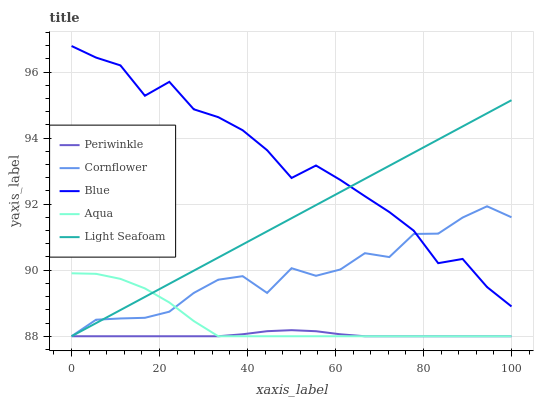Does Periwinkle have the minimum area under the curve?
Answer yes or no. Yes. Does Blue have the maximum area under the curve?
Answer yes or no. Yes. Does Cornflower have the minimum area under the curve?
Answer yes or no. No. Does Cornflower have the maximum area under the curve?
Answer yes or no. No. Is Light Seafoam the smoothest?
Answer yes or no. Yes. Is Blue the roughest?
Answer yes or no. Yes. Is Cornflower the smoothest?
Answer yes or no. No. Is Cornflower the roughest?
Answer yes or no. No. Does Cornflower have the lowest value?
Answer yes or no. Yes. Does Blue have the highest value?
Answer yes or no. Yes. Does Cornflower have the highest value?
Answer yes or no. No. Is Periwinkle less than Blue?
Answer yes or no. Yes. Is Blue greater than Aqua?
Answer yes or no. Yes. Does Light Seafoam intersect Periwinkle?
Answer yes or no. Yes. Is Light Seafoam less than Periwinkle?
Answer yes or no. No. Is Light Seafoam greater than Periwinkle?
Answer yes or no. No. Does Periwinkle intersect Blue?
Answer yes or no. No. 